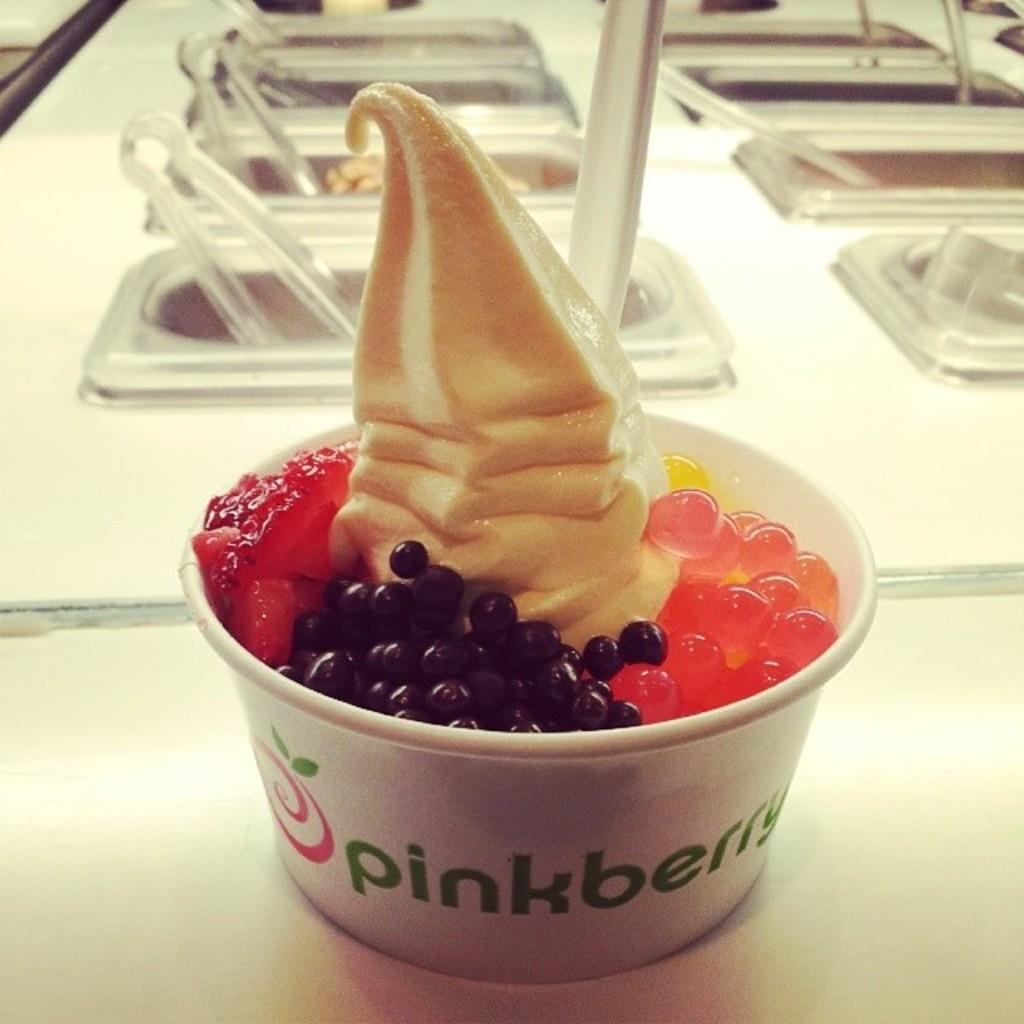What is contained in the cup that is visible in the image? There is food in a cup in the image. What else can be seen in the image besides the cup? There are containers and serving tongs visible in the image. What type of science experiment is being conducted with the pan in the image? There is no pan present in the image, and therefore no science experiment can be observed. 